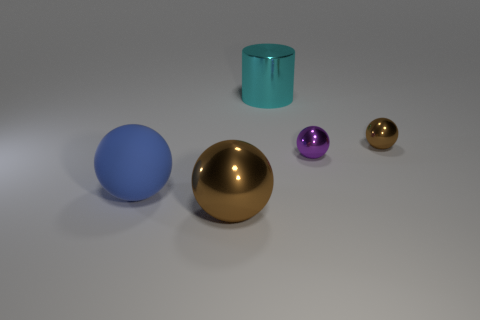What number of things are big cyan metallic cylinders that are behind the purple metallic thing or large matte objects?
Provide a succinct answer. 2. The other large thing that is made of the same material as the large brown thing is what color?
Your answer should be very brief. Cyan. Is there a brown metal object that has the same size as the cyan cylinder?
Your answer should be compact. Yes. Does the small shiny ball right of the tiny purple shiny thing have the same color as the big metal sphere?
Provide a short and direct response. Yes. There is a metal thing that is on the right side of the big cyan cylinder and in front of the tiny brown metallic object; what is its color?
Your response must be concise. Purple. There is a cyan thing that is the same size as the blue sphere; what shape is it?
Offer a terse response. Cylinder. Are there any other big brown metallic objects of the same shape as the big brown metallic thing?
Offer a terse response. No. There is a brown sphere that is in front of the matte object; is its size the same as the purple ball?
Offer a terse response. No. What is the size of the metal object that is both left of the purple thing and behind the large matte ball?
Keep it short and to the point. Large. What number of other objects are there of the same material as the big brown object?
Provide a short and direct response. 3. 